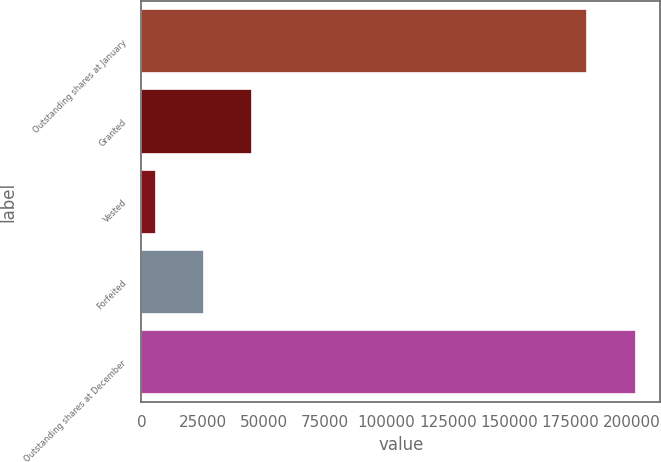Convert chart. <chart><loc_0><loc_0><loc_500><loc_500><bar_chart><fcel>Outstanding shares at January<fcel>Granted<fcel>Vested<fcel>Forfeited<fcel>Outstanding shares at December<nl><fcel>181650<fcel>44954<fcel>5800<fcel>25377<fcel>201570<nl></chart> 